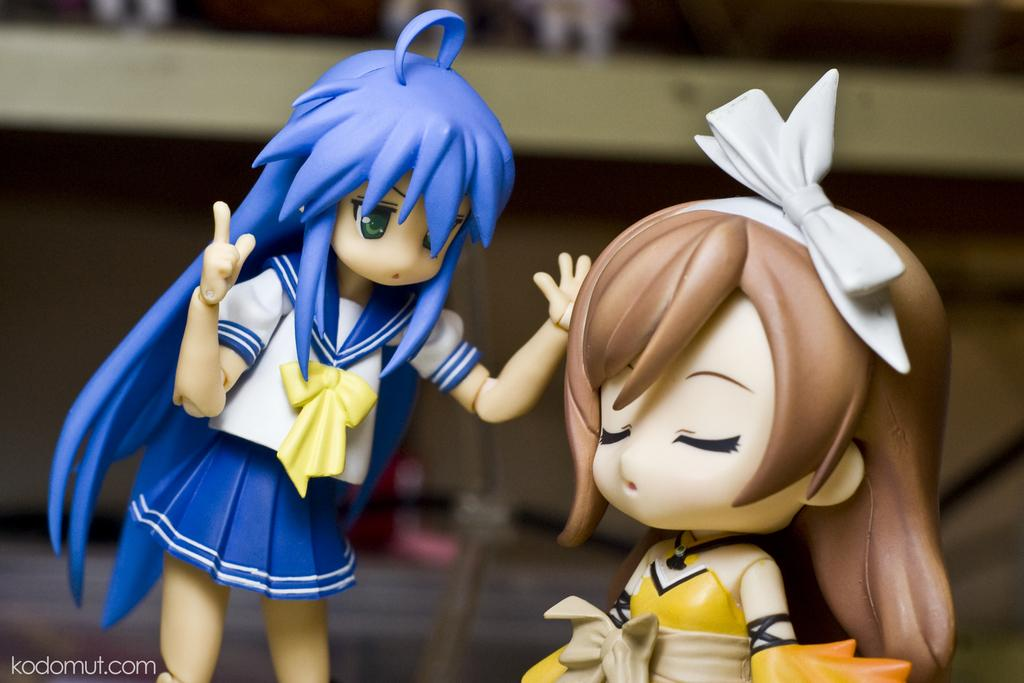What objects can be seen in the image? There are toys in the image. Can you describe the background of the image? The background of the image is blurred. Is there any text or writing present in the image? Yes, there is text or writing in the left bottom corner of the image. What is the profit margin of the machine depicted in the image? There is no machine present in the image, so it is not possible to determine the profit margin. 